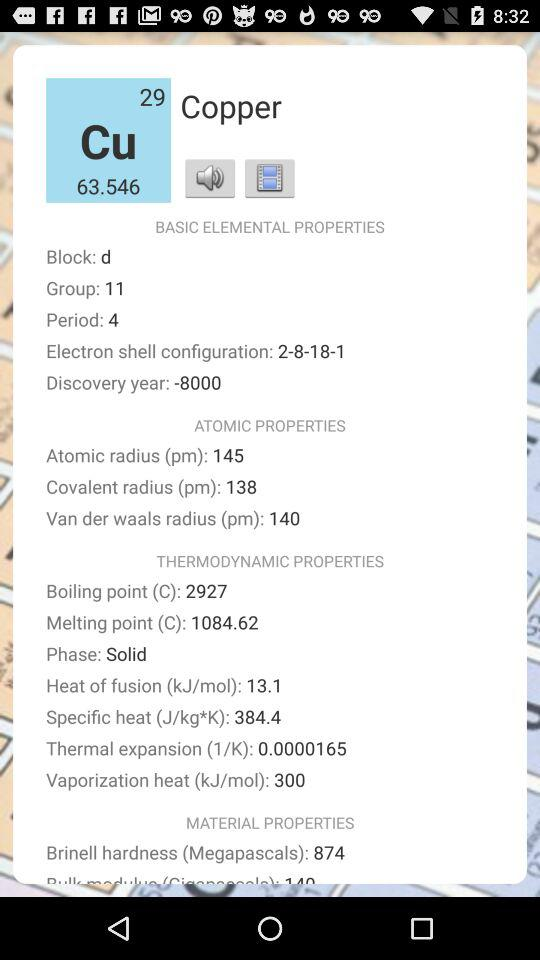What is the boiling point of copper? The boiling point of copper is 2927 °C. 